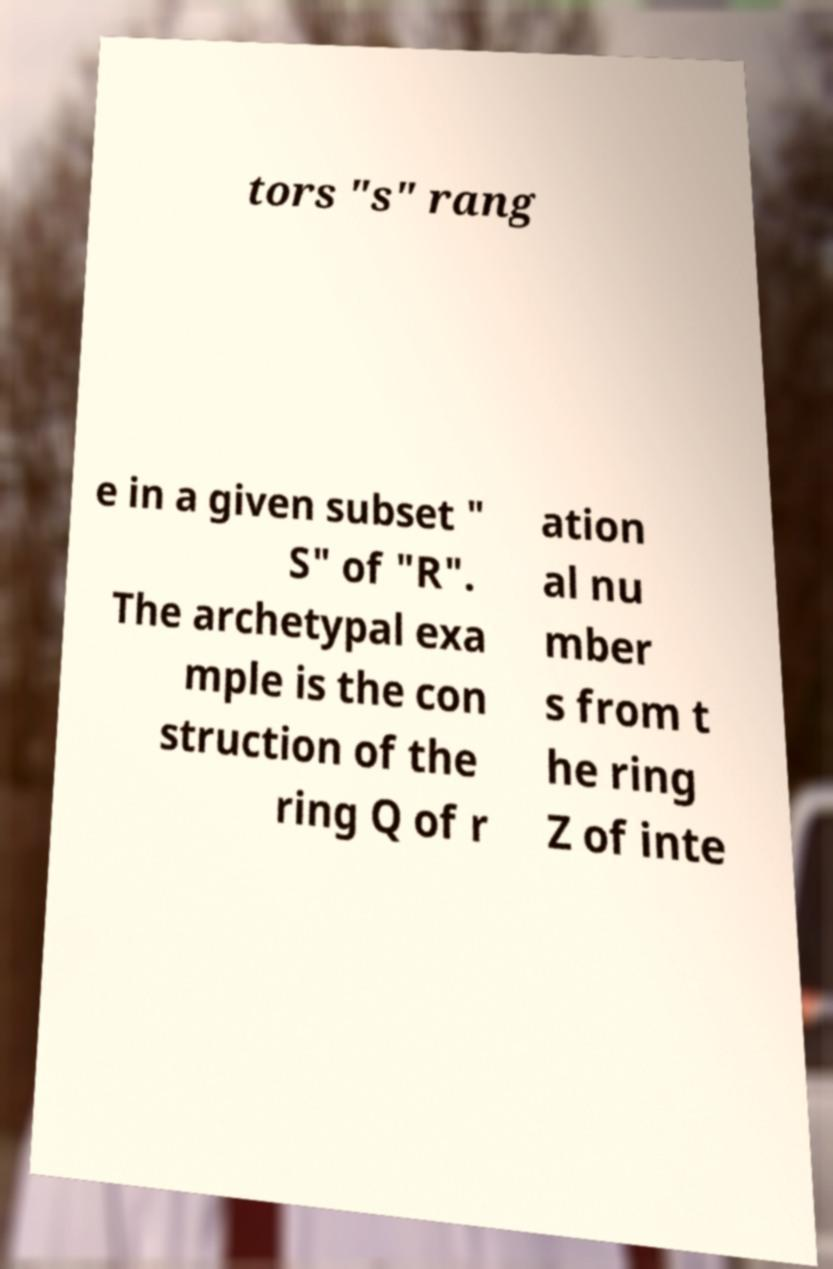Please read and relay the text visible in this image. What does it say? tors "s" rang e in a given subset " S" of "R". The archetypal exa mple is the con struction of the ring Q of r ation al nu mber s from t he ring Z of inte 